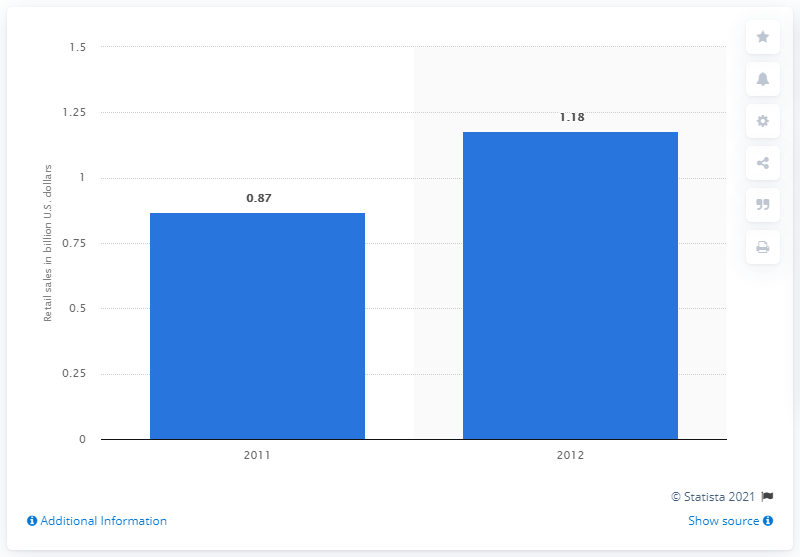Give some essential details in this illustration. In 2011, the total sales of lawn and garden products in the retail industry amounted to approximately $87 million. 